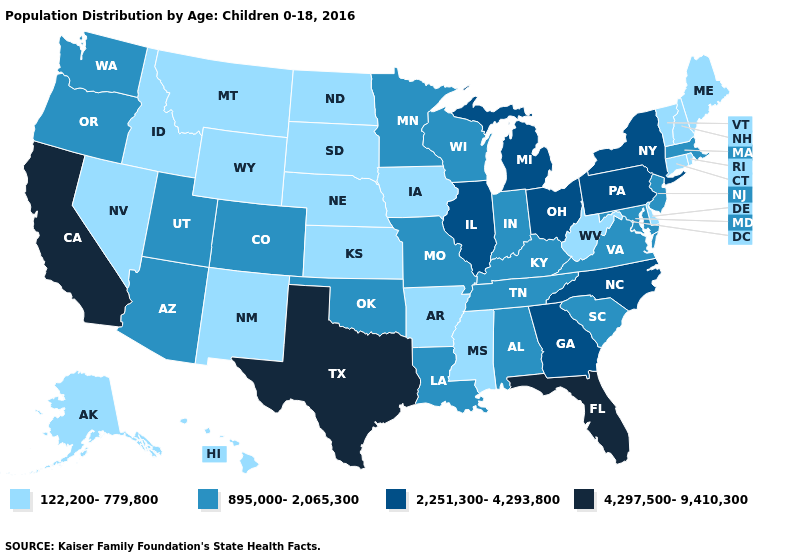What is the value of Maine?
Give a very brief answer. 122,200-779,800. How many symbols are there in the legend?
Answer briefly. 4. Name the states that have a value in the range 2,251,300-4,293,800?
Give a very brief answer. Georgia, Illinois, Michigan, New York, North Carolina, Ohio, Pennsylvania. What is the highest value in the USA?
Short answer required. 4,297,500-9,410,300. Name the states that have a value in the range 4,297,500-9,410,300?
Concise answer only. California, Florida, Texas. Name the states that have a value in the range 122,200-779,800?
Keep it brief. Alaska, Arkansas, Connecticut, Delaware, Hawaii, Idaho, Iowa, Kansas, Maine, Mississippi, Montana, Nebraska, Nevada, New Hampshire, New Mexico, North Dakota, Rhode Island, South Dakota, Vermont, West Virginia, Wyoming. What is the highest value in the Northeast ?
Keep it brief. 2,251,300-4,293,800. What is the lowest value in the West?
Keep it brief. 122,200-779,800. Which states have the lowest value in the USA?
Quick response, please. Alaska, Arkansas, Connecticut, Delaware, Hawaii, Idaho, Iowa, Kansas, Maine, Mississippi, Montana, Nebraska, Nevada, New Hampshire, New Mexico, North Dakota, Rhode Island, South Dakota, Vermont, West Virginia, Wyoming. What is the lowest value in the USA?
Concise answer only. 122,200-779,800. Does Florida have the highest value in the USA?
Quick response, please. Yes. What is the highest value in the USA?
Give a very brief answer. 4,297,500-9,410,300. What is the value of Texas?
Short answer required. 4,297,500-9,410,300. Which states have the lowest value in the USA?
Be succinct. Alaska, Arkansas, Connecticut, Delaware, Hawaii, Idaho, Iowa, Kansas, Maine, Mississippi, Montana, Nebraska, Nevada, New Hampshire, New Mexico, North Dakota, Rhode Island, South Dakota, Vermont, West Virginia, Wyoming. What is the value of Maryland?
Short answer required. 895,000-2,065,300. 